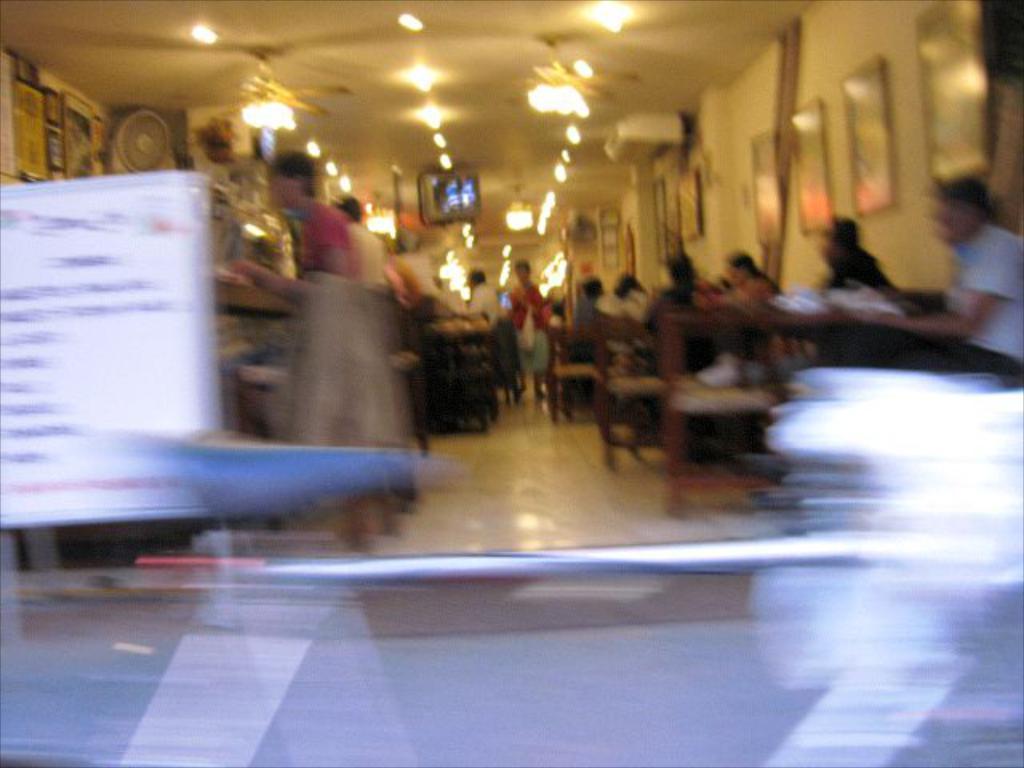Please provide a concise description of this image. The image is blurred. The image is taken inside a building. In the image we can see chairs, people, tables, framed, board and various objects. At the top we can see light and television. 